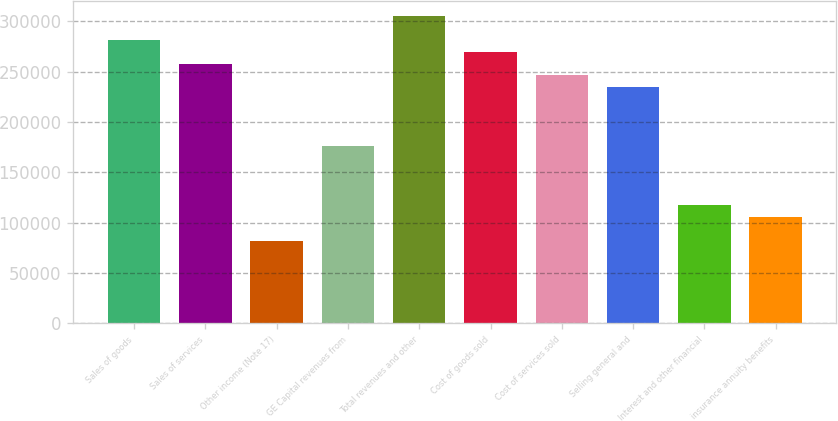<chart> <loc_0><loc_0><loc_500><loc_500><bar_chart><fcel>Sales of goods<fcel>Sales of services<fcel>Other income (Note 17)<fcel>GE Capital revenues from<fcel>Total revenues and other<fcel>Cost of goods sold<fcel>Cost of services sold<fcel>Selling general and<fcel>Interest and other financial<fcel>insurance annuity benefits<nl><fcel>281240<fcel>257804<fcel>82029.1<fcel>175776<fcel>304677<fcel>269522<fcel>246085<fcel>234367<fcel>117184<fcel>105466<nl></chart> 